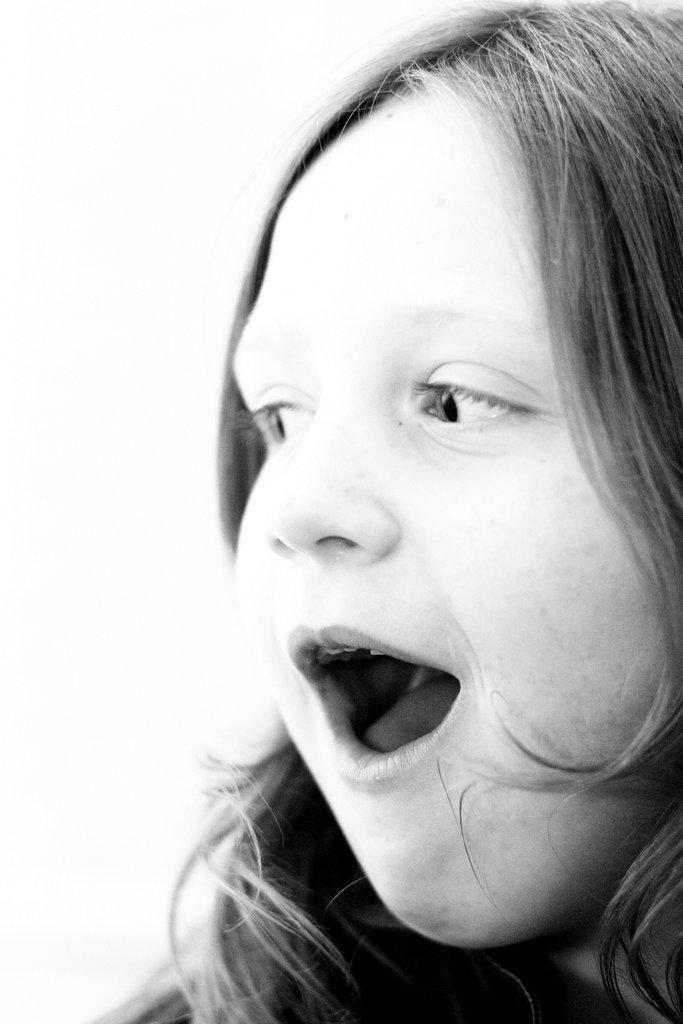Describe this image in one or two sentences. This is a girl. 